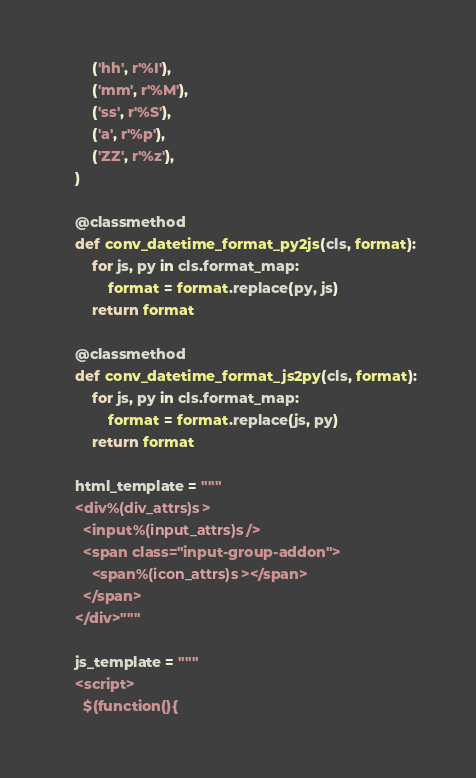<code> <loc_0><loc_0><loc_500><loc_500><_Python_>        ('hh', r'%I'),
        ('mm', r'%M'),
        ('ss', r'%S'),
        ('a', r'%p'),
        ('ZZ', r'%z'),
    )

    @classmethod
    def conv_datetime_format_py2js(cls, format):
        for js, py in cls.format_map:
            format = format.replace(py, js)
        return format

    @classmethod
    def conv_datetime_format_js2py(cls, format):
        for js, py in cls.format_map:
            format = format.replace(js, py)
        return format

    html_template = """
    <div%(div_attrs)s>
      <input%(input_attrs)s/>
      <span class="input-group-addon">
        <span%(icon_attrs)s></span>
      </span>
    </div>"""

    js_template = """
    <script>
      $(function(){</code> 